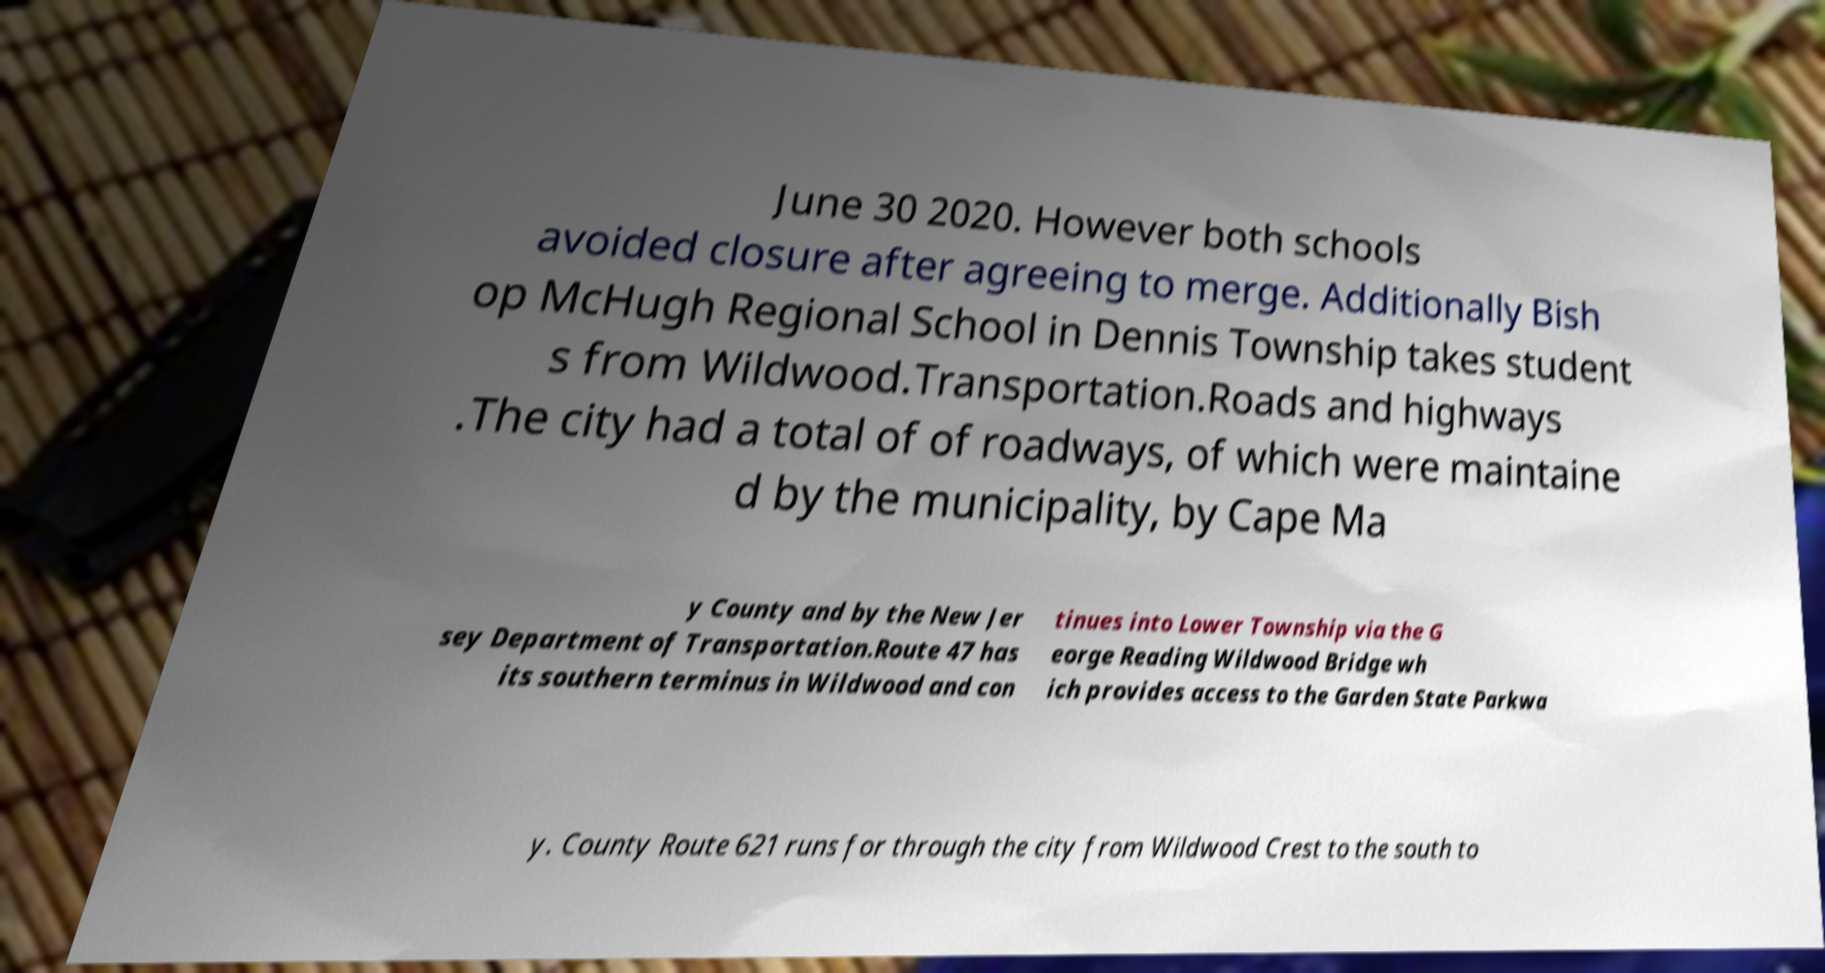Could you extract and type out the text from this image? June 30 2020. However both schools avoided closure after agreeing to merge. Additionally Bish op McHugh Regional School in Dennis Township takes student s from Wildwood.Transportation.Roads and highways .The city had a total of of roadways, of which were maintaine d by the municipality, by Cape Ma y County and by the New Jer sey Department of Transportation.Route 47 has its southern terminus in Wildwood and con tinues into Lower Township via the G eorge Reading Wildwood Bridge wh ich provides access to the Garden State Parkwa y. County Route 621 runs for through the city from Wildwood Crest to the south to 